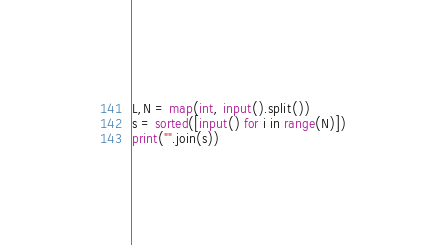Convert code to text. <code><loc_0><loc_0><loc_500><loc_500><_Python_>L,N = map(int, input().split())
s = sorted([input() for i in range(N)])
print("".join(s))</code> 